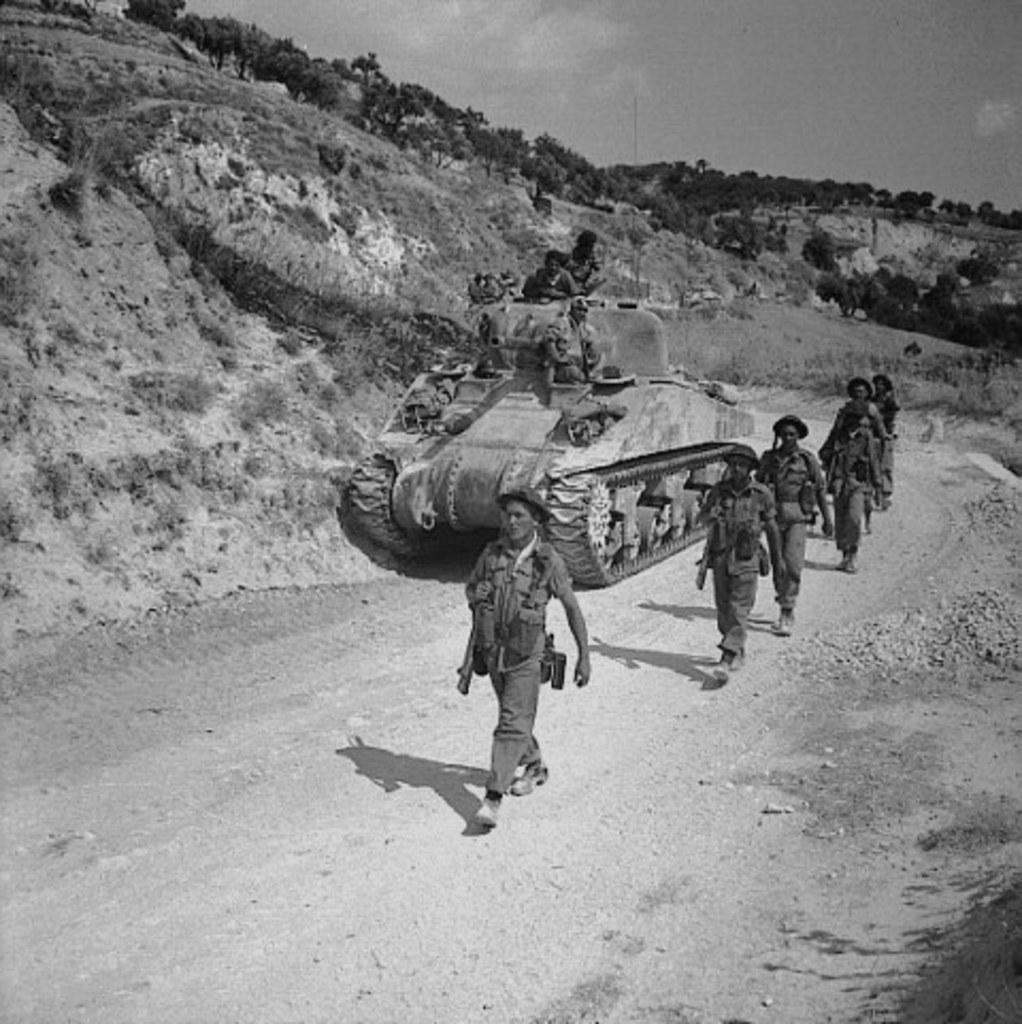How would you summarize this image in a sentence or two? It looks like a black and white picture. We can see there are a group of people walking on the path and some people sitting on the tank. Behind the tank there are trees, hills and the sky. 